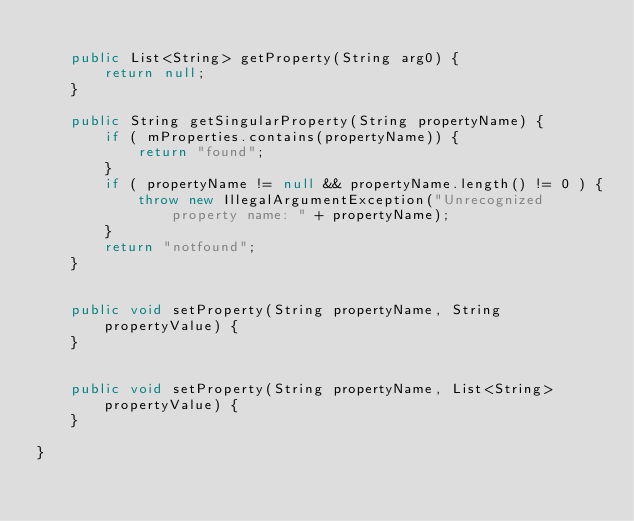Convert code to text. <code><loc_0><loc_0><loc_500><loc_500><_Java_>
    public List<String> getProperty(String arg0) {
        return null;
    }

    public String getSingularProperty(String propertyName) {
        if ( mProperties.contains(propertyName)) {
            return "found";
        }
        if ( propertyName != null && propertyName.length() != 0 ) {
            throw new IllegalArgumentException("Unrecognized property name: " + propertyName);
        }
        return "notfound";
    }


    public void setProperty(String propertyName, String propertyValue) {
    }


    public void setProperty(String propertyName, List<String> propertyValue) {
    }

}
</code> 